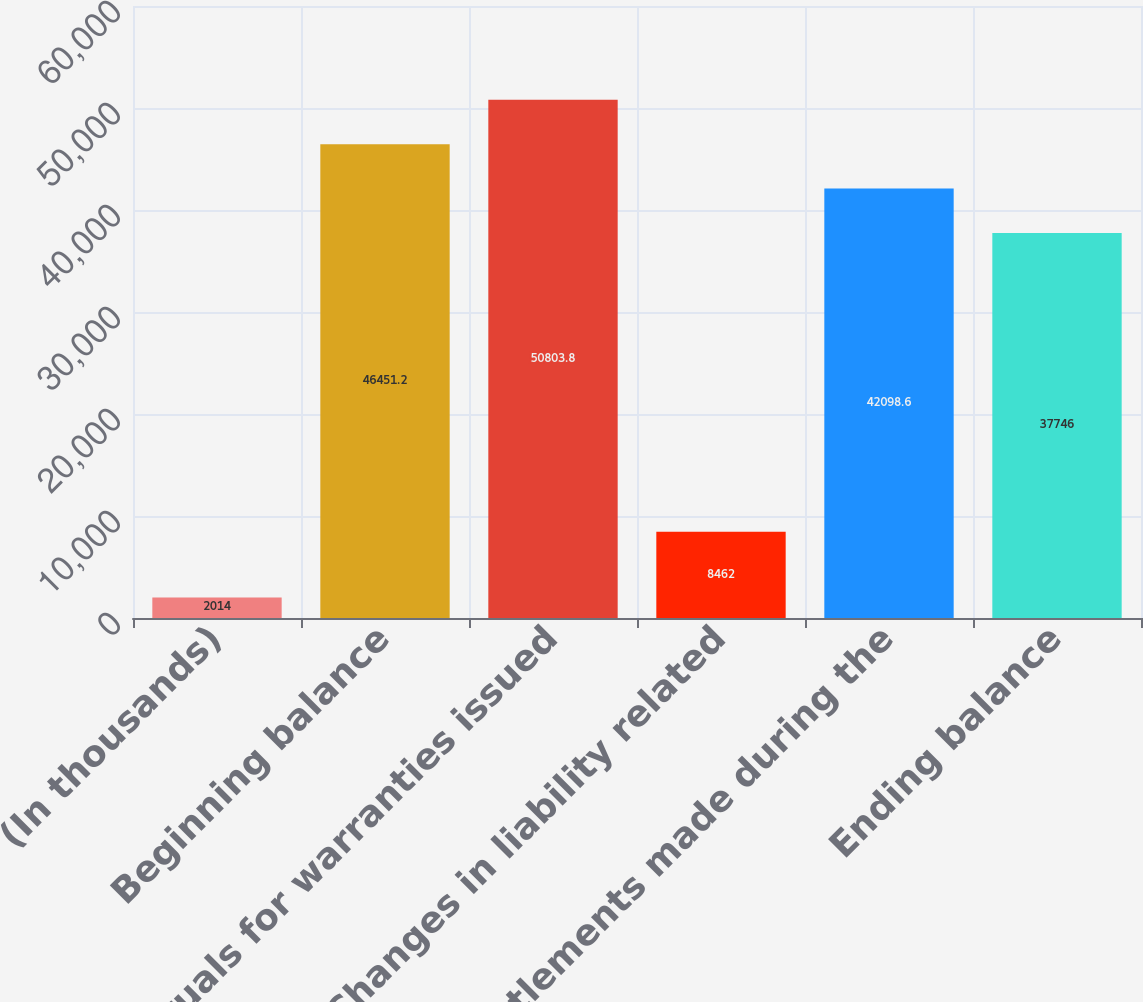Convert chart. <chart><loc_0><loc_0><loc_500><loc_500><bar_chart><fcel>(In thousands)<fcel>Beginning balance<fcel>Accruals for warranties issued<fcel>Changes in liability related<fcel>Settlements made during the<fcel>Ending balance<nl><fcel>2014<fcel>46451.2<fcel>50803.8<fcel>8462<fcel>42098.6<fcel>37746<nl></chart> 